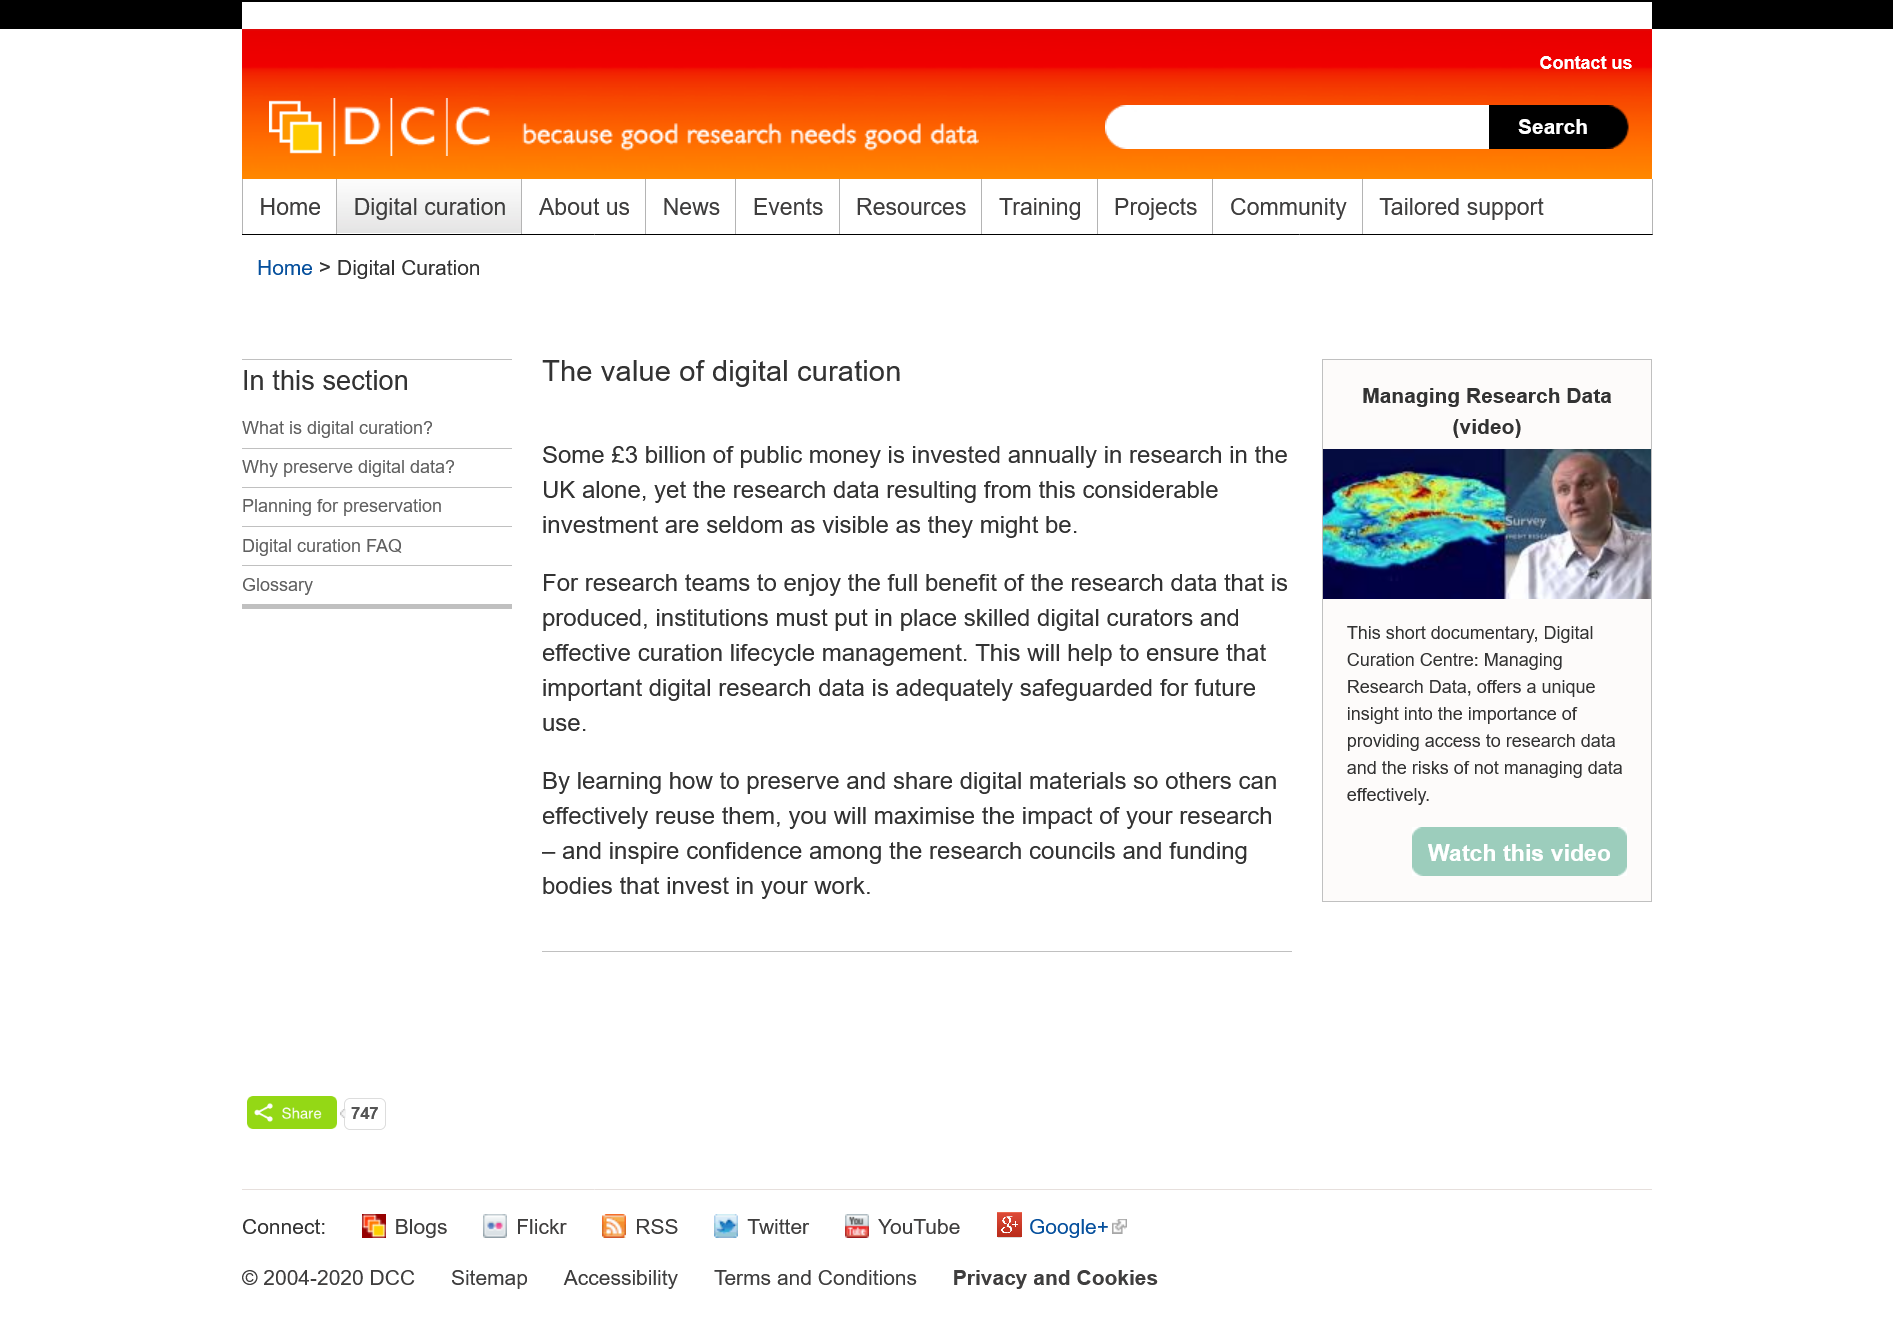Draw attention to some important aspects in this diagram. To effectively safeguard digital research data for future use, institutions must employ skilled digital curators and implement effective curation lifecycle management. Each year, approximately 3 billion pounds of public funds are invested in research in the UK. The value of digital curation in this context cannot be overstated. To ensure that research teams fully enjoy the benefits of research data, institutions must employ skilled digital curators and implement effective curation lifecycle management. 